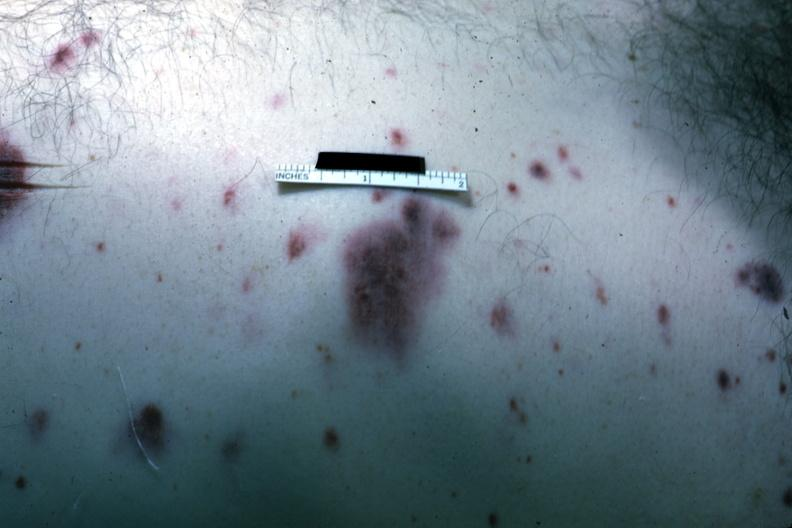what is present?
Answer the question using a single word or phrase. Petechial and purpuric hemorrhages 